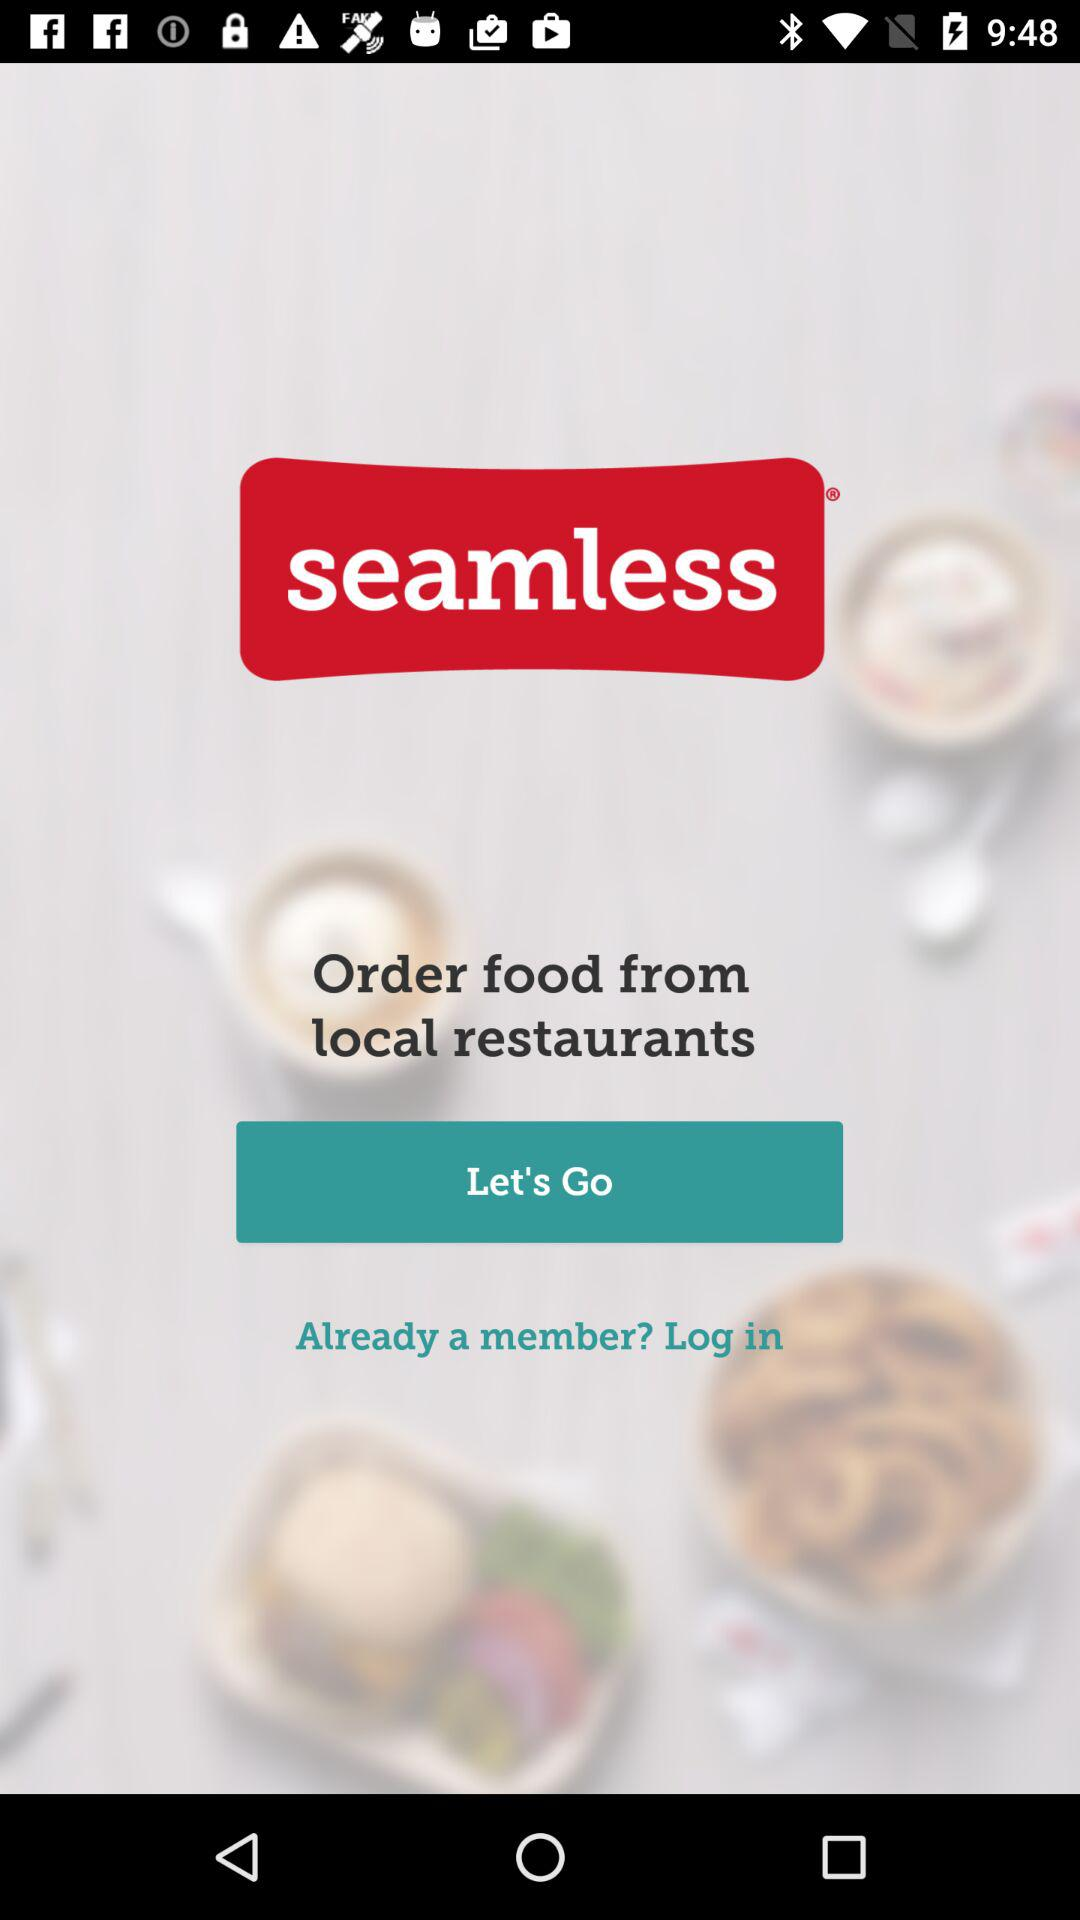What is the version number?
When the provided information is insufficient, respond with <no answer>. <no answer> 